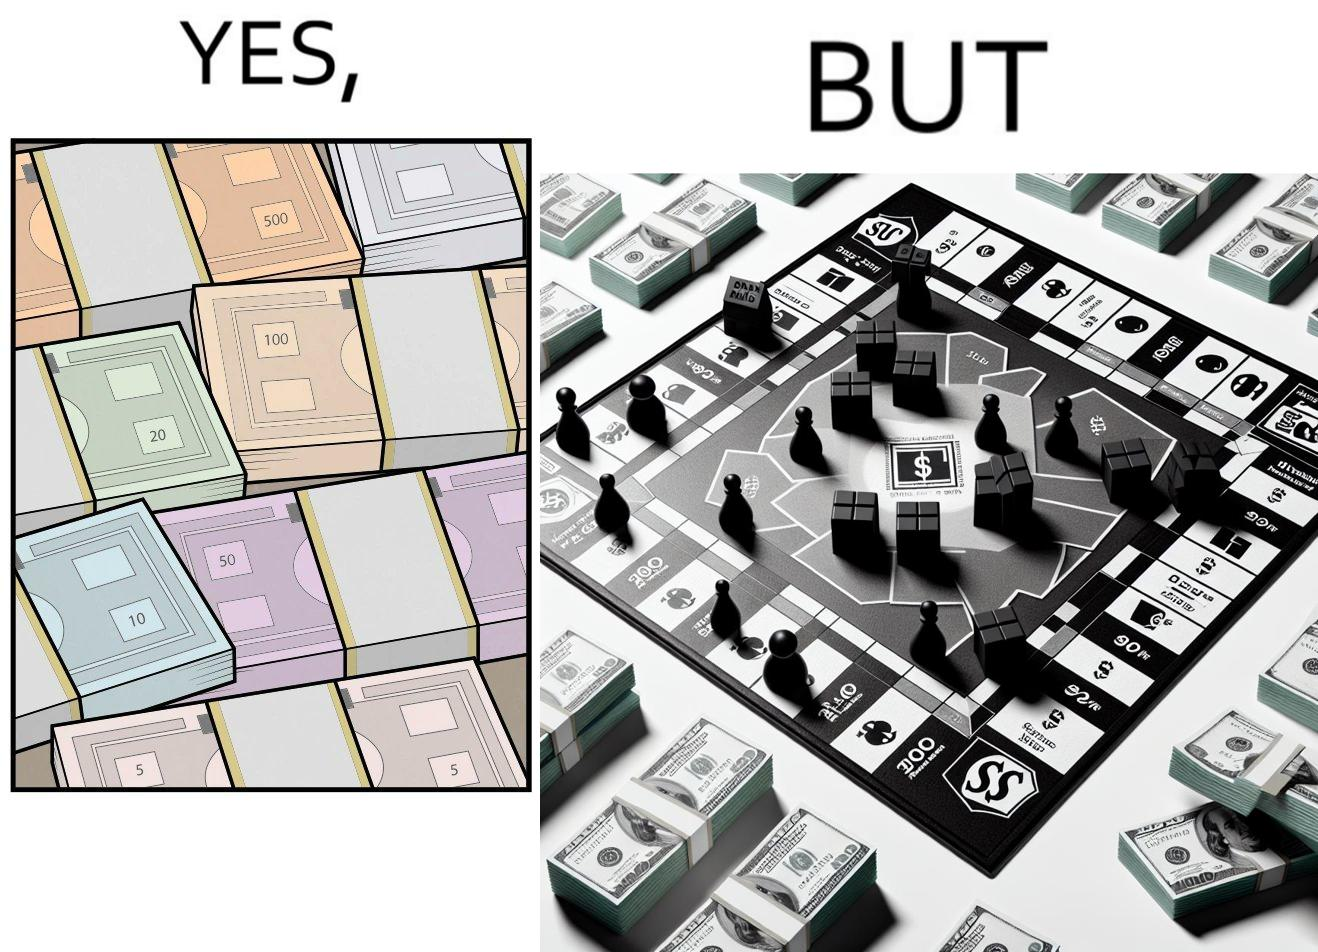Is this image satirical or non-satirical? Yes, this image is satirical. 